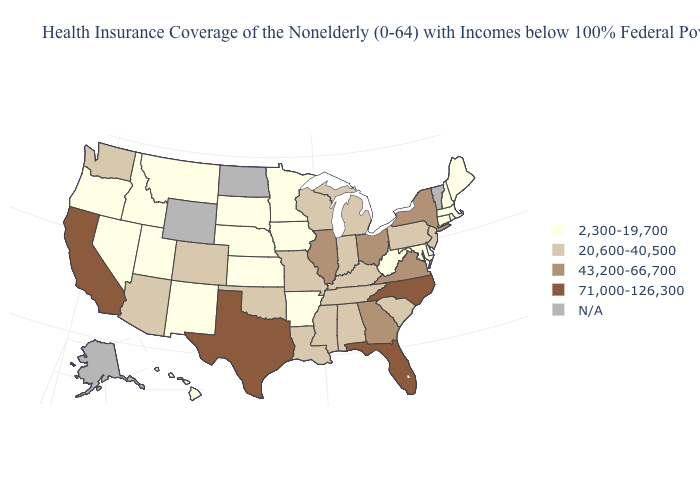Does California have the highest value in the USA?
Keep it brief. Yes. What is the value of New Mexico?
Short answer required. 2,300-19,700. Name the states that have a value in the range 43,200-66,700?
Quick response, please. Georgia, Illinois, New York, Ohio, Virginia. Among the states that border Virginia , which have the lowest value?
Short answer required. Maryland, West Virginia. Name the states that have a value in the range 71,000-126,300?
Answer briefly. California, Florida, North Carolina, Texas. Name the states that have a value in the range 71,000-126,300?
Answer briefly. California, Florida, North Carolina, Texas. What is the lowest value in the USA?
Concise answer only. 2,300-19,700. Which states hav the highest value in the South?
Short answer required. Florida, North Carolina, Texas. Among the states that border Wyoming , does Nebraska have the lowest value?
Quick response, please. Yes. Name the states that have a value in the range 71,000-126,300?
Short answer required. California, Florida, North Carolina, Texas. Among the states that border Virginia , does Tennessee have the highest value?
Short answer required. No. 